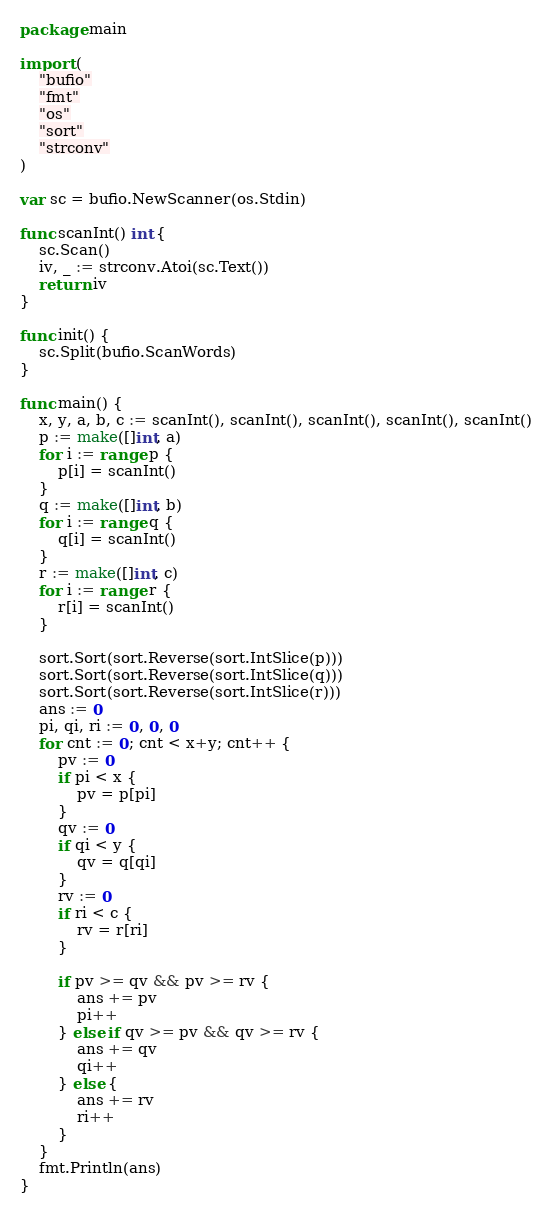Convert code to text. <code><loc_0><loc_0><loc_500><loc_500><_Go_>package main

import (
	"bufio"
	"fmt"
	"os"
	"sort"
	"strconv"
)

var sc = bufio.NewScanner(os.Stdin)

func scanInt() int {
	sc.Scan()
	iv, _ := strconv.Atoi(sc.Text())
	return iv
}

func init() {
	sc.Split(bufio.ScanWords)
}

func main() {
	x, y, a, b, c := scanInt(), scanInt(), scanInt(), scanInt(), scanInt()
	p := make([]int, a)
	for i := range p {
		p[i] = scanInt()
	}
	q := make([]int, b)
	for i := range q {
		q[i] = scanInt()
	}
	r := make([]int, c)
	for i := range r {
		r[i] = scanInt()
	}

	sort.Sort(sort.Reverse(sort.IntSlice(p)))
	sort.Sort(sort.Reverse(sort.IntSlice(q)))
	sort.Sort(sort.Reverse(sort.IntSlice(r)))
	ans := 0
	pi, qi, ri := 0, 0, 0
	for cnt := 0; cnt < x+y; cnt++ {
		pv := 0
		if pi < x {
			pv = p[pi]
		}
		qv := 0
		if qi < y {
			qv = q[qi]
		}
		rv := 0
		if ri < c {
			rv = r[ri]
		}

		if pv >= qv && pv >= rv {
			ans += pv
			pi++
		} else if qv >= pv && qv >= rv {
			ans += qv
			qi++
		} else {
			ans += rv
			ri++
		}
	}
	fmt.Println(ans)
}
</code> 